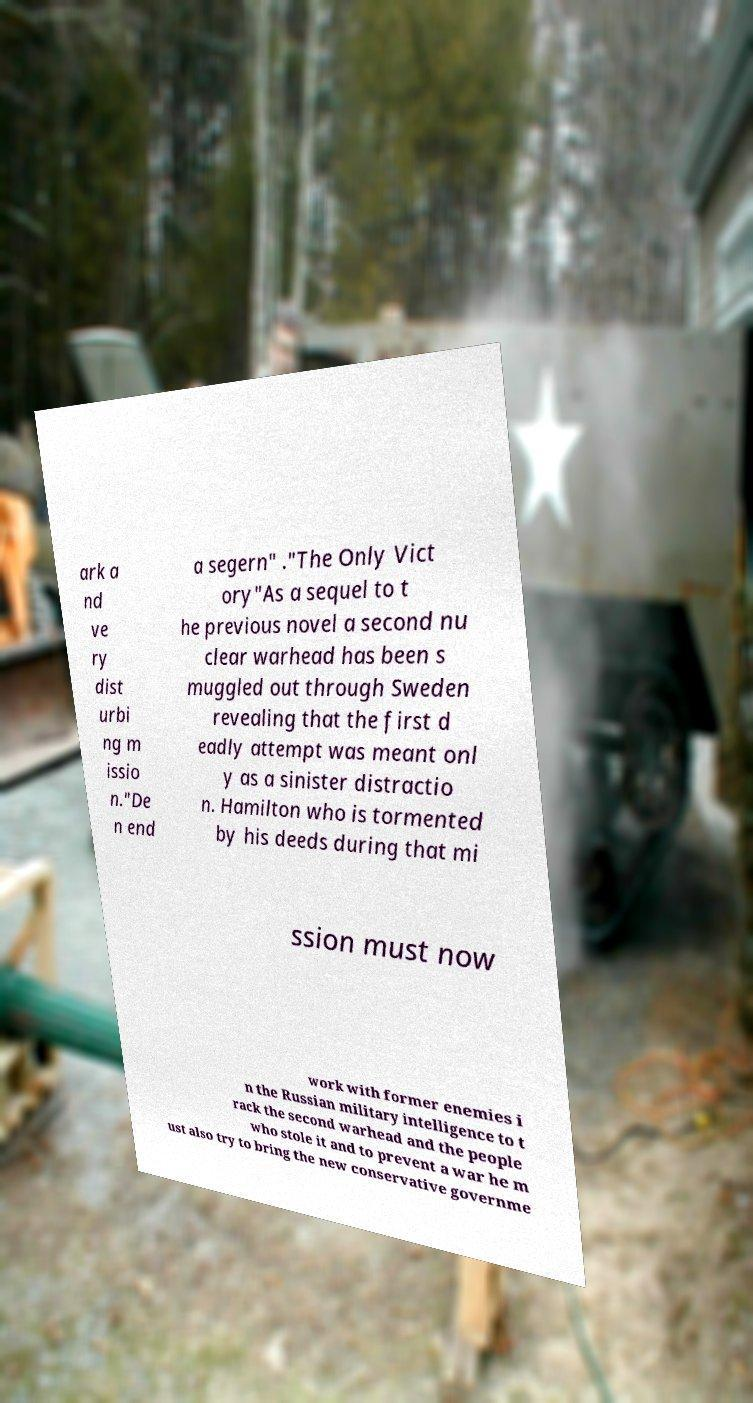Please read and relay the text visible in this image. What does it say? ark a nd ve ry dist urbi ng m issio n."De n end a segern" ."The Only Vict ory"As a sequel to t he previous novel a second nu clear warhead has been s muggled out through Sweden revealing that the first d eadly attempt was meant onl y as a sinister distractio n. Hamilton who is tormented by his deeds during that mi ssion must now work with former enemies i n the Russian military intelligence to t rack the second warhead and the people who stole it and to prevent a war he m ust also try to bring the new conservative governme 